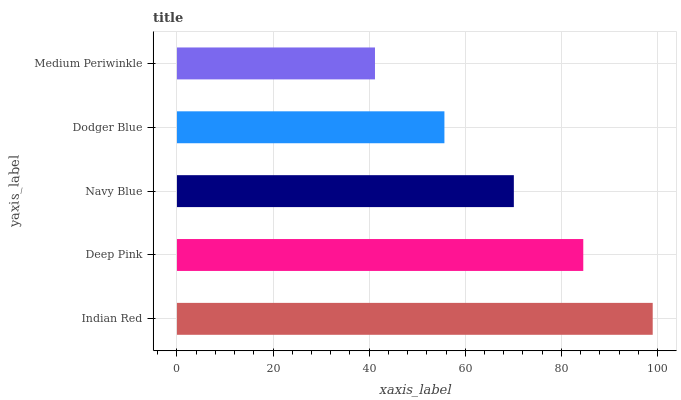Is Medium Periwinkle the minimum?
Answer yes or no. Yes. Is Indian Red the maximum?
Answer yes or no. Yes. Is Deep Pink the minimum?
Answer yes or no. No. Is Deep Pink the maximum?
Answer yes or no. No. Is Indian Red greater than Deep Pink?
Answer yes or no. Yes. Is Deep Pink less than Indian Red?
Answer yes or no. Yes. Is Deep Pink greater than Indian Red?
Answer yes or no. No. Is Indian Red less than Deep Pink?
Answer yes or no. No. Is Navy Blue the high median?
Answer yes or no. Yes. Is Navy Blue the low median?
Answer yes or no. Yes. Is Dodger Blue the high median?
Answer yes or no. No. Is Dodger Blue the low median?
Answer yes or no. No. 